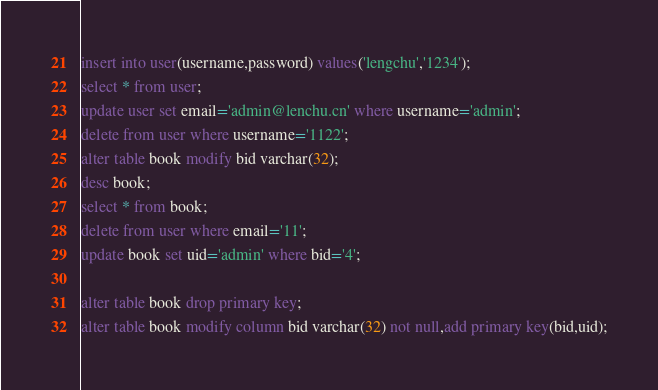Convert code to text. <code><loc_0><loc_0><loc_500><loc_500><_SQL_>insert into user(username,password) values('lengchu','1234');
select * from user;
update user set email='admin@lenchu.cn' where username='admin';
delete from user where username='1122';
alter table book modify bid varchar(32);
desc book;
select * from book;
delete from user where email='11';
update book set uid='admin' where bid='4';

alter table book drop primary key;
alter table book modify column bid varchar(32) not null,add primary key(bid,uid);</code> 